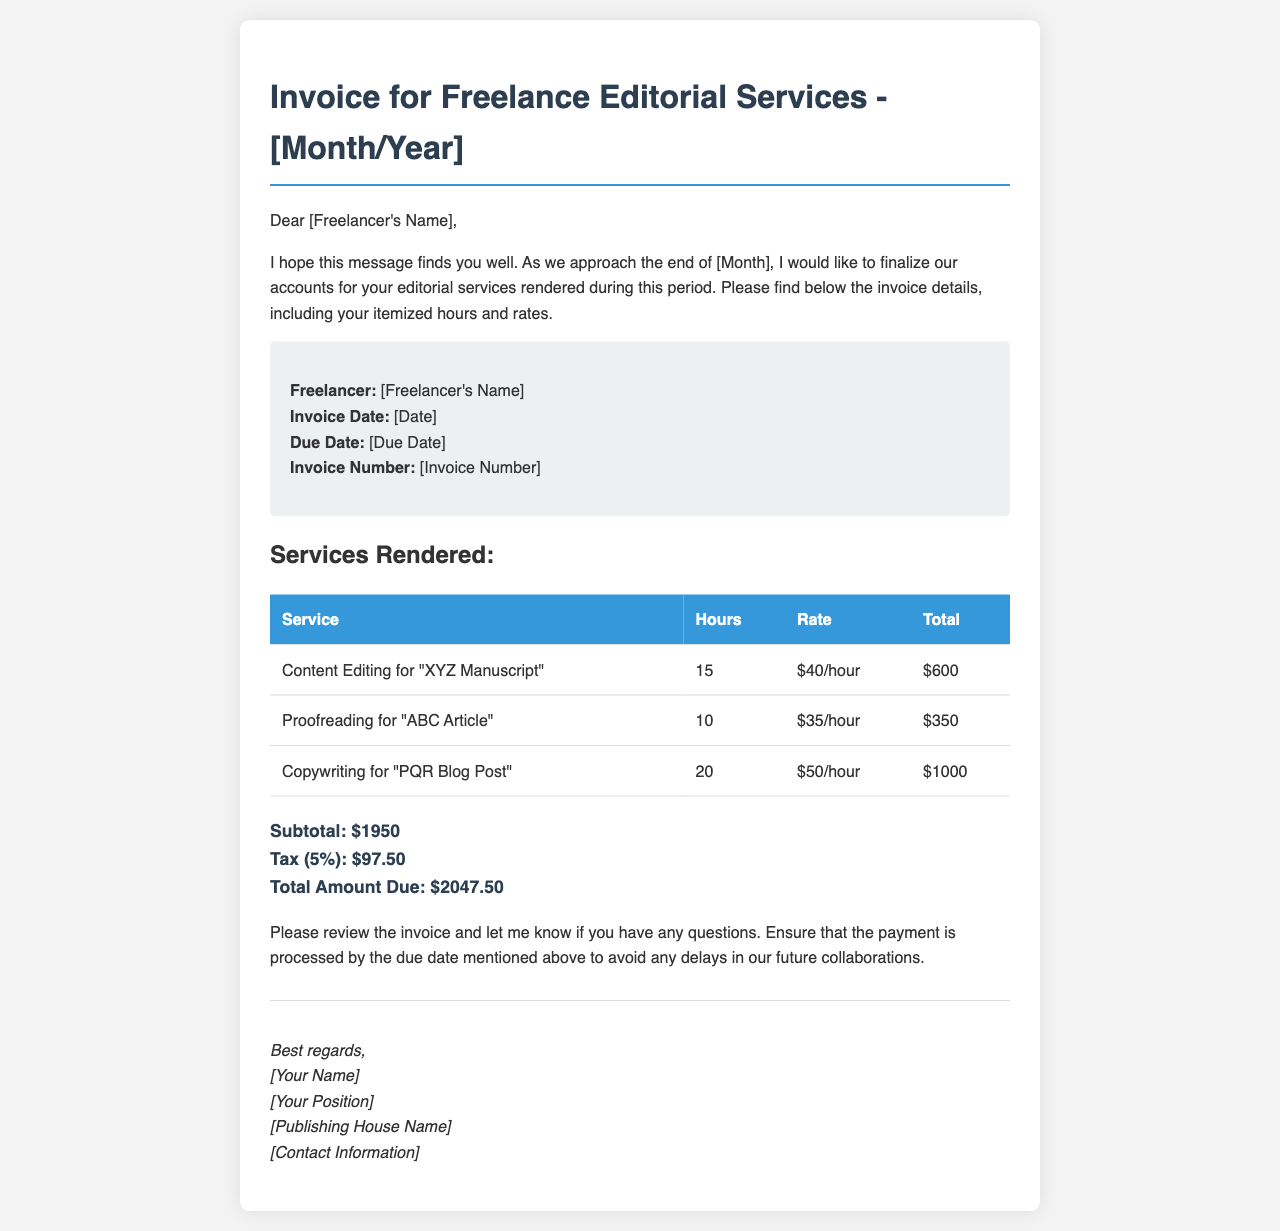What is the freelancer's name? The freelancer's name is mentioned in the invoice details.
Answer: [Freelancer's Name] What is the invoice date? The invoice date is specified in the invoice details section.
Answer: [Date] What services are listed in the invoice? The invoice mentions three services rendered by the freelancer.
Answer: Content Editing, Proofreading, Copywriting What is the total amount due? The total amount due is calculated at the bottom of the invoice.
Answer: $2047.50 How many hours were spent on content editing? The hours for content editing are provided in the services rendered table.
Answer: 15 What is the tax percentage applied to the subtotal? The tax percentage is mentioned directly in the invoice.
Answer: 5% What is the rate for proofreading services? The rate per hour for proofreading is indicated in the document.
Answer: $35/hour By when should the payment be processed? The due date for payment is mentioned in the invoice details.
Answer: [Due Date] How much does the freelancer earn for copywriting? The total for copywriting is calculated in the services rendered table.
Answer: $1000 